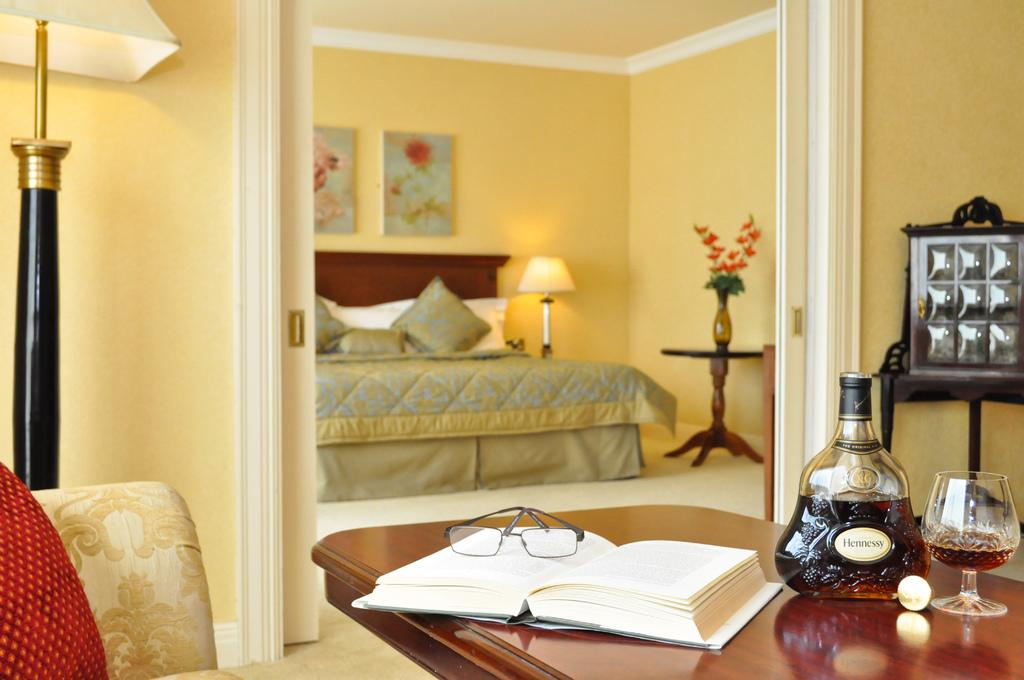What type of furniture is present in the image? There is a bed in the image. What type of lighting is present in the image? There is a lamp in the image. What type of decorations are on the wall? There are photo frames on the wall. What type of reading material is present in the image? There is a book on a table. What type of eyewear is present in the image? There is a pair of spectacles on a table. What type of beverage container is present in the image? There is a bottle on a table. What type of drinking glass is present in the image? There is a glass on a table. What type of decorative item is present in the image? There is a flower vase on a table. What type of fact can be seen in the image? There is no fact present in the image; it contains a bed, lamp, photo frames, book, spectacles, bottle, glass, and flower vase. What type of turkey is present in the image? There is no turkey present in the image; it contains a bed, lamp, photo frames, book, spectacles, bottle, glass, and flower vase. What type of milk is present in the image? There is no milk present in the image; it contains a bed, lamp, photo frames, book, spectacles, bottle, glass, and flower vase. 